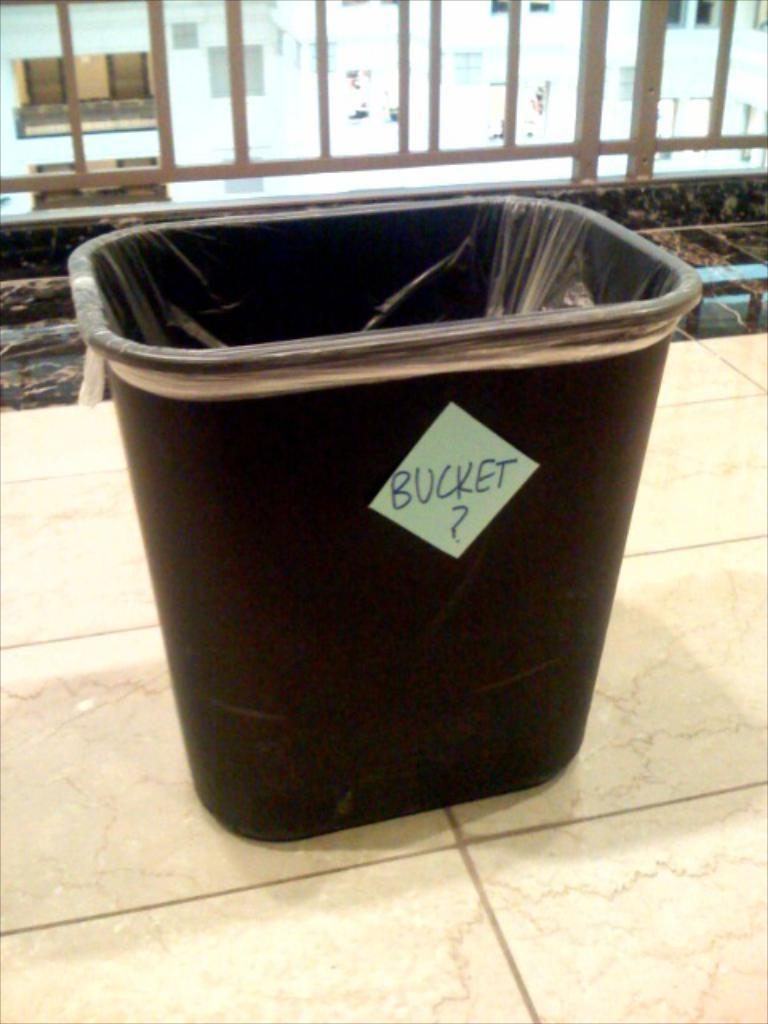What object is located in the foreground of the image? There is a black bucket in the foreground of the image. What is the bucket resting on? The bucket is on a surface. What can be seen in the background of the image? There is a railing and a building in the background of the image. What type of activity is the bucket participating in within the image? The bucket is not participating in any activity within the image; it is simply resting on a surface. What substance is the bucket filled with in the image? The facts provided do not mention any substance inside the bucket, so we cannot determine what it might contain. 